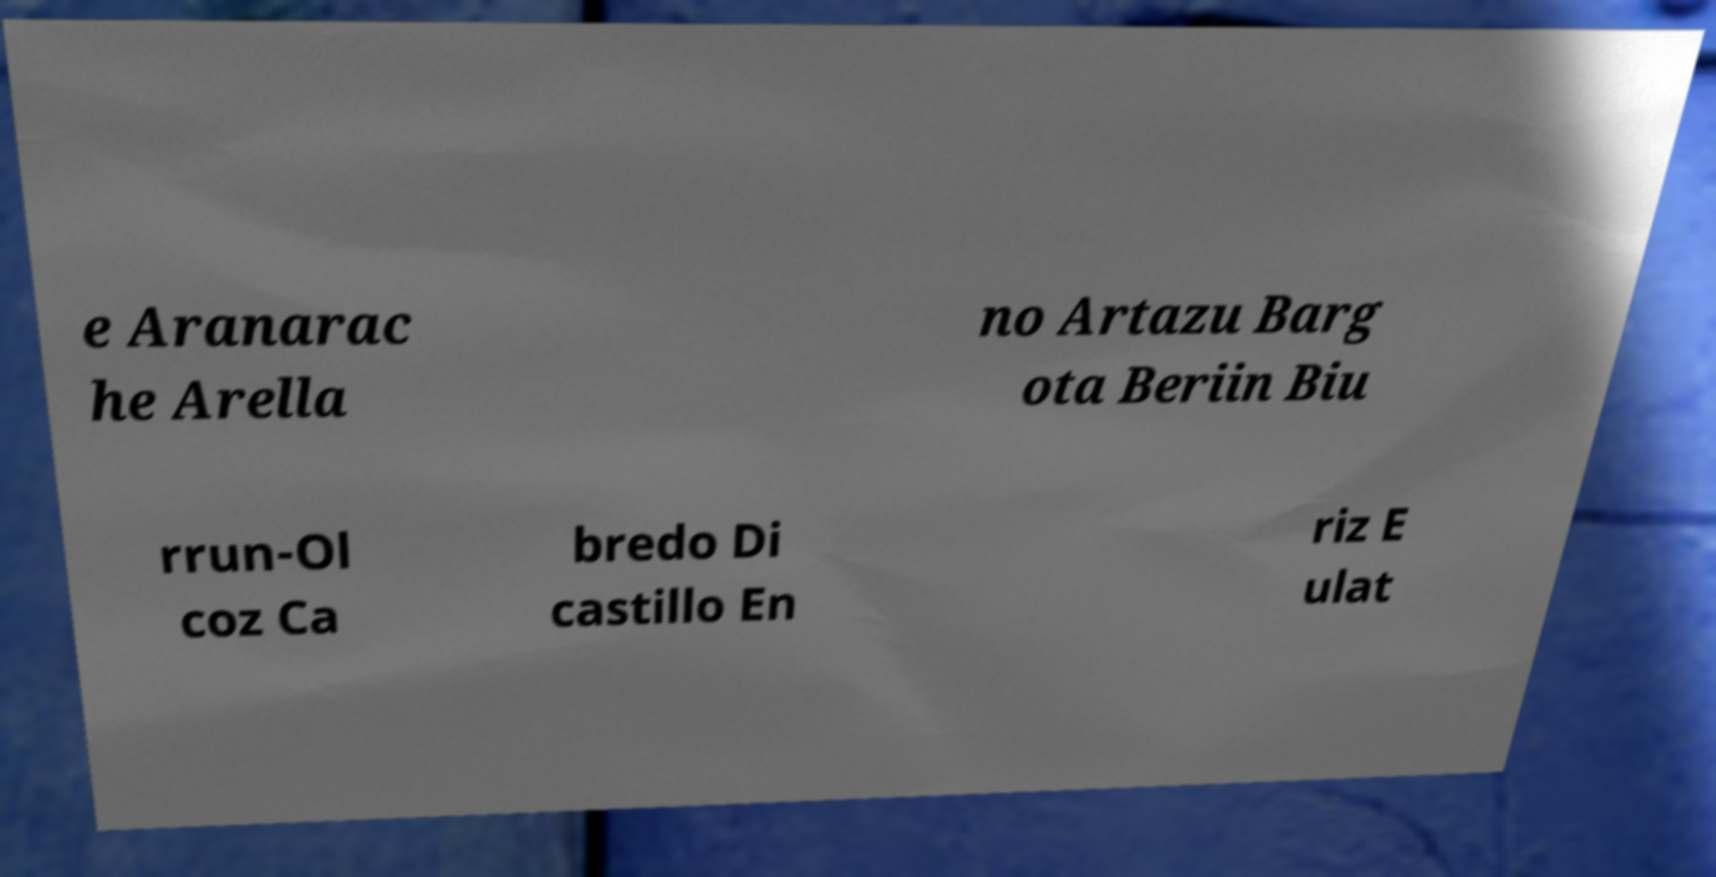There's text embedded in this image that I need extracted. Can you transcribe it verbatim? e Aranarac he Arella no Artazu Barg ota Beriin Biu rrun-Ol coz Ca bredo Di castillo En riz E ulat 